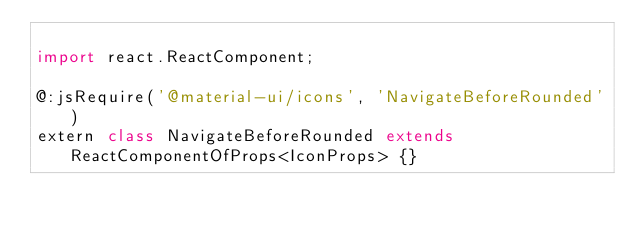Convert code to text. <code><loc_0><loc_0><loc_500><loc_500><_Haxe_>
import react.ReactComponent;

@:jsRequire('@material-ui/icons', 'NavigateBeforeRounded')
extern class NavigateBeforeRounded extends ReactComponentOfProps<IconProps> {}
</code> 